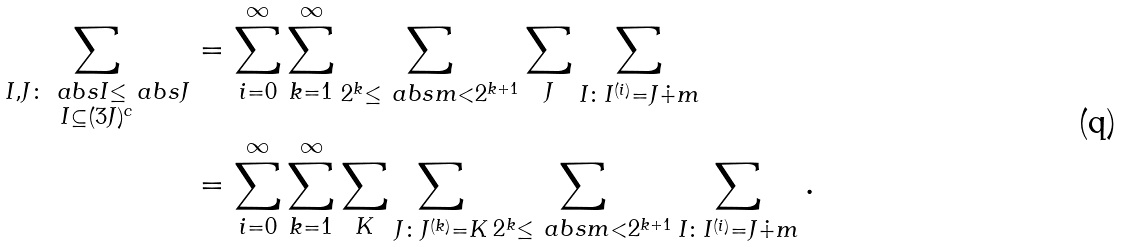<formula> <loc_0><loc_0><loc_500><loc_500>\sum _ { \substack { I , J \colon \ a b s { I } \leq \ a b s { J } \\ I \subseteq ( 3 J ) ^ { c } } } & = \sum _ { i = 0 } ^ { \infty } \sum _ { k = 1 } ^ { \infty } \sum _ { 2 ^ { k } \leq \ a b s { m } < 2 ^ { k + 1 } } \sum _ { J } \sum _ { I \colon I ^ { ( i ) } = J \dot { + } m } \\ & = \sum _ { i = 0 } ^ { \infty } \sum _ { k = 1 } ^ { \infty } \sum _ { K } \sum _ { J \colon J ^ { ( k ) } = K } \sum _ { 2 ^ { k } \leq \ a b s { m } < 2 ^ { k + 1 } } \sum _ { I \colon I ^ { ( i ) } = J \dot { + } m } .</formula> 